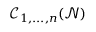Convert formula to latex. <formula><loc_0><loc_0><loc_500><loc_500>\ m a t h s c r { C } _ { 1 , \dots , n } ( \mathcal { N } )</formula> 